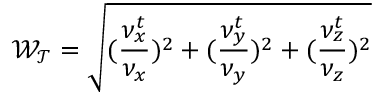Convert formula to latex. <formula><loc_0><loc_0><loc_500><loc_500>\mathcal { W _ { T } } = \sqrt { ( \frac { \nu _ { x } ^ { t } } { \nu _ { x } } ) ^ { 2 } + ( \frac { \nu _ { y } ^ { t } } { \nu _ { y } } ) ^ { 2 } + ( \frac { \nu _ { z } ^ { t } } { \nu _ { z } } ) ^ { 2 } }</formula> 